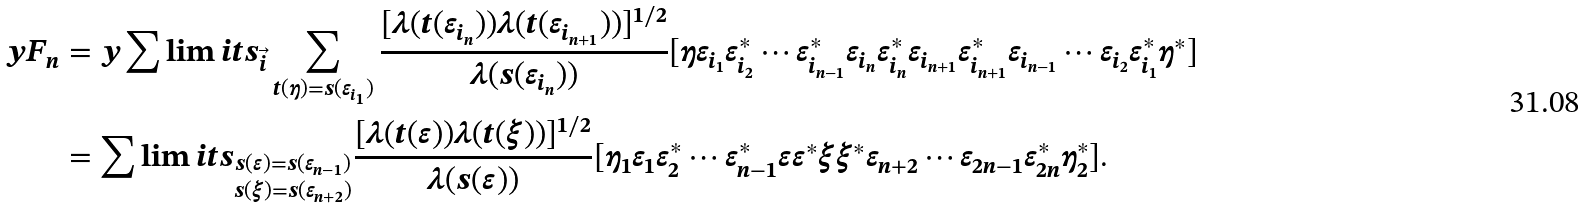Convert formula to latex. <formula><loc_0><loc_0><loc_500><loc_500>y F _ { n } & = y \sum \lim i t s _ { \vec { i } } \sum _ { t ( \eta ) = s ( \varepsilon _ { i _ { 1 } } ) } \frac { [ \lambda ( t ( \varepsilon _ { i _ { n } } ) ) \lambda ( t ( \varepsilon _ { i _ { n + 1 } } ) ) ] ^ { 1 / 2 } } { \lambda ( s ( \varepsilon _ { i _ { n } } ) ) } [ \eta \varepsilon _ { i _ { 1 } } \varepsilon _ { i _ { 2 } } ^ { * } \cdots \varepsilon _ { i _ { n - 1 } } ^ { * } \varepsilon _ { i _ { n } } \varepsilon _ { i _ { n } } ^ { * } \varepsilon _ { i _ { n + 1 } } \varepsilon _ { i _ { n + 1 } } ^ { * } \varepsilon _ { i _ { n - 1 } } \cdots \varepsilon _ { i _ { 2 } } \varepsilon _ { i _ { 1 } } ^ { * } \eta ^ { * } ] \\ & = \sum \lim i t s _ { \substack { s ( \varepsilon ) = s ( \varepsilon _ { n - 1 } ) \\ s ( \xi ) = s ( \varepsilon _ { n + 2 } ) } } \frac { [ \lambda ( t ( \varepsilon ) ) \lambda ( t ( \xi ) ) ] ^ { 1 / 2 } } { \lambda ( s ( \varepsilon ) ) } [ \eta _ { 1 } \varepsilon _ { 1 } \varepsilon _ { 2 } ^ { * } \cdots \varepsilon _ { n - 1 } ^ { * } \varepsilon \varepsilon ^ { * } \xi \xi ^ { * } \varepsilon _ { n + 2 } \cdots \varepsilon _ { 2 n - 1 } \varepsilon _ { 2 n } ^ { * } \eta _ { 2 } ^ { * } ] .</formula> 